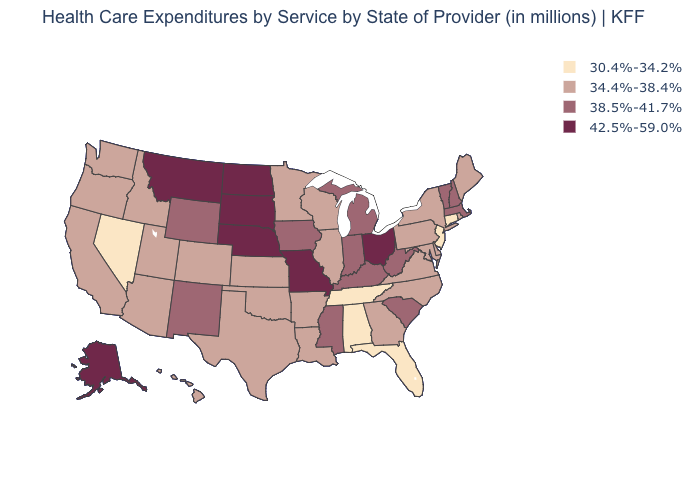Does the first symbol in the legend represent the smallest category?
Write a very short answer. Yes. What is the highest value in the USA?
Answer briefly. 42.5%-59.0%. How many symbols are there in the legend?
Give a very brief answer. 4. Among the states that border Oregon , which have the lowest value?
Give a very brief answer. Nevada. What is the value of New Hampshire?
Answer briefly. 38.5%-41.7%. Does Alabama have the same value as Florida?
Keep it brief. Yes. Name the states that have a value in the range 38.5%-41.7%?
Concise answer only. Indiana, Iowa, Kentucky, Massachusetts, Michigan, Mississippi, New Hampshire, New Mexico, South Carolina, Vermont, West Virginia, Wyoming. Does Nevada have the lowest value in the USA?
Short answer required. Yes. Name the states that have a value in the range 30.4%-34.2%?
Answer briefly. Alabama, Connecticut, Florida, Nevada, New Jersey, Tennessee. What is the value of Illinois?
Short answer required. 34.4%-38.4%. Does Missouri have a higher value than New Hampshire?
Keep it brief. Yes. What is the lowest value in states that border Wisconsin?
Write a very short answer. 34.4%-38.4%. Name the states that have a value in the range 42.5%-59.0%?
Keep it brief. Alaska, Missouri, Montana, Nebraska, North Dakota, Ohio, South Dakota. Name the states that have a value in the range 34.4%-38.4%?
Keep it brief. Arizona, Arkansas, California, Colorado, Delaware, Georgia, Hawaii, Idaho, Illinois, Kansas, Louisiana, Maine, Maryland, Minnesota, New York, North Carolina, Oklahoma, Oregon, Pennsylvania, Rhode Island, Texas, Utah, Virginia, Washington, Wisconsin. Does Georgia have the highest value in the USA?
Write a very short answer. No. 